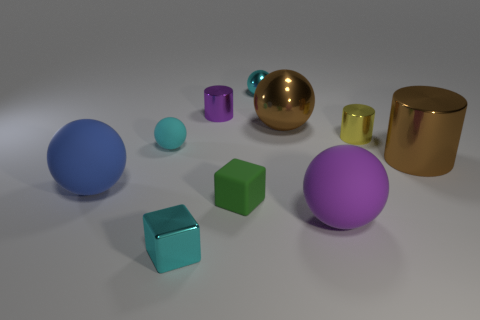Subtract all blue spheres. How many spheres are left? 4 Subtract all brown spheres. How many spheres are left? 4 Subtract all red balls. Subtract all blue cylinders. How many balls are left? 5 Subtract all cylinders. How many objects are left? 7 Add 6 tiny cyan shiny blocks. How many tiny cyan shiny blocks are left? 7 Add 5 tiny brown rubber objects. How many tiny brown rubber objects exist? 5 Subtract 1 green cubes. How many objects are left? 9 Subtract all cyan matte things. Subtract all red metal objects. How many objects are left? 9 